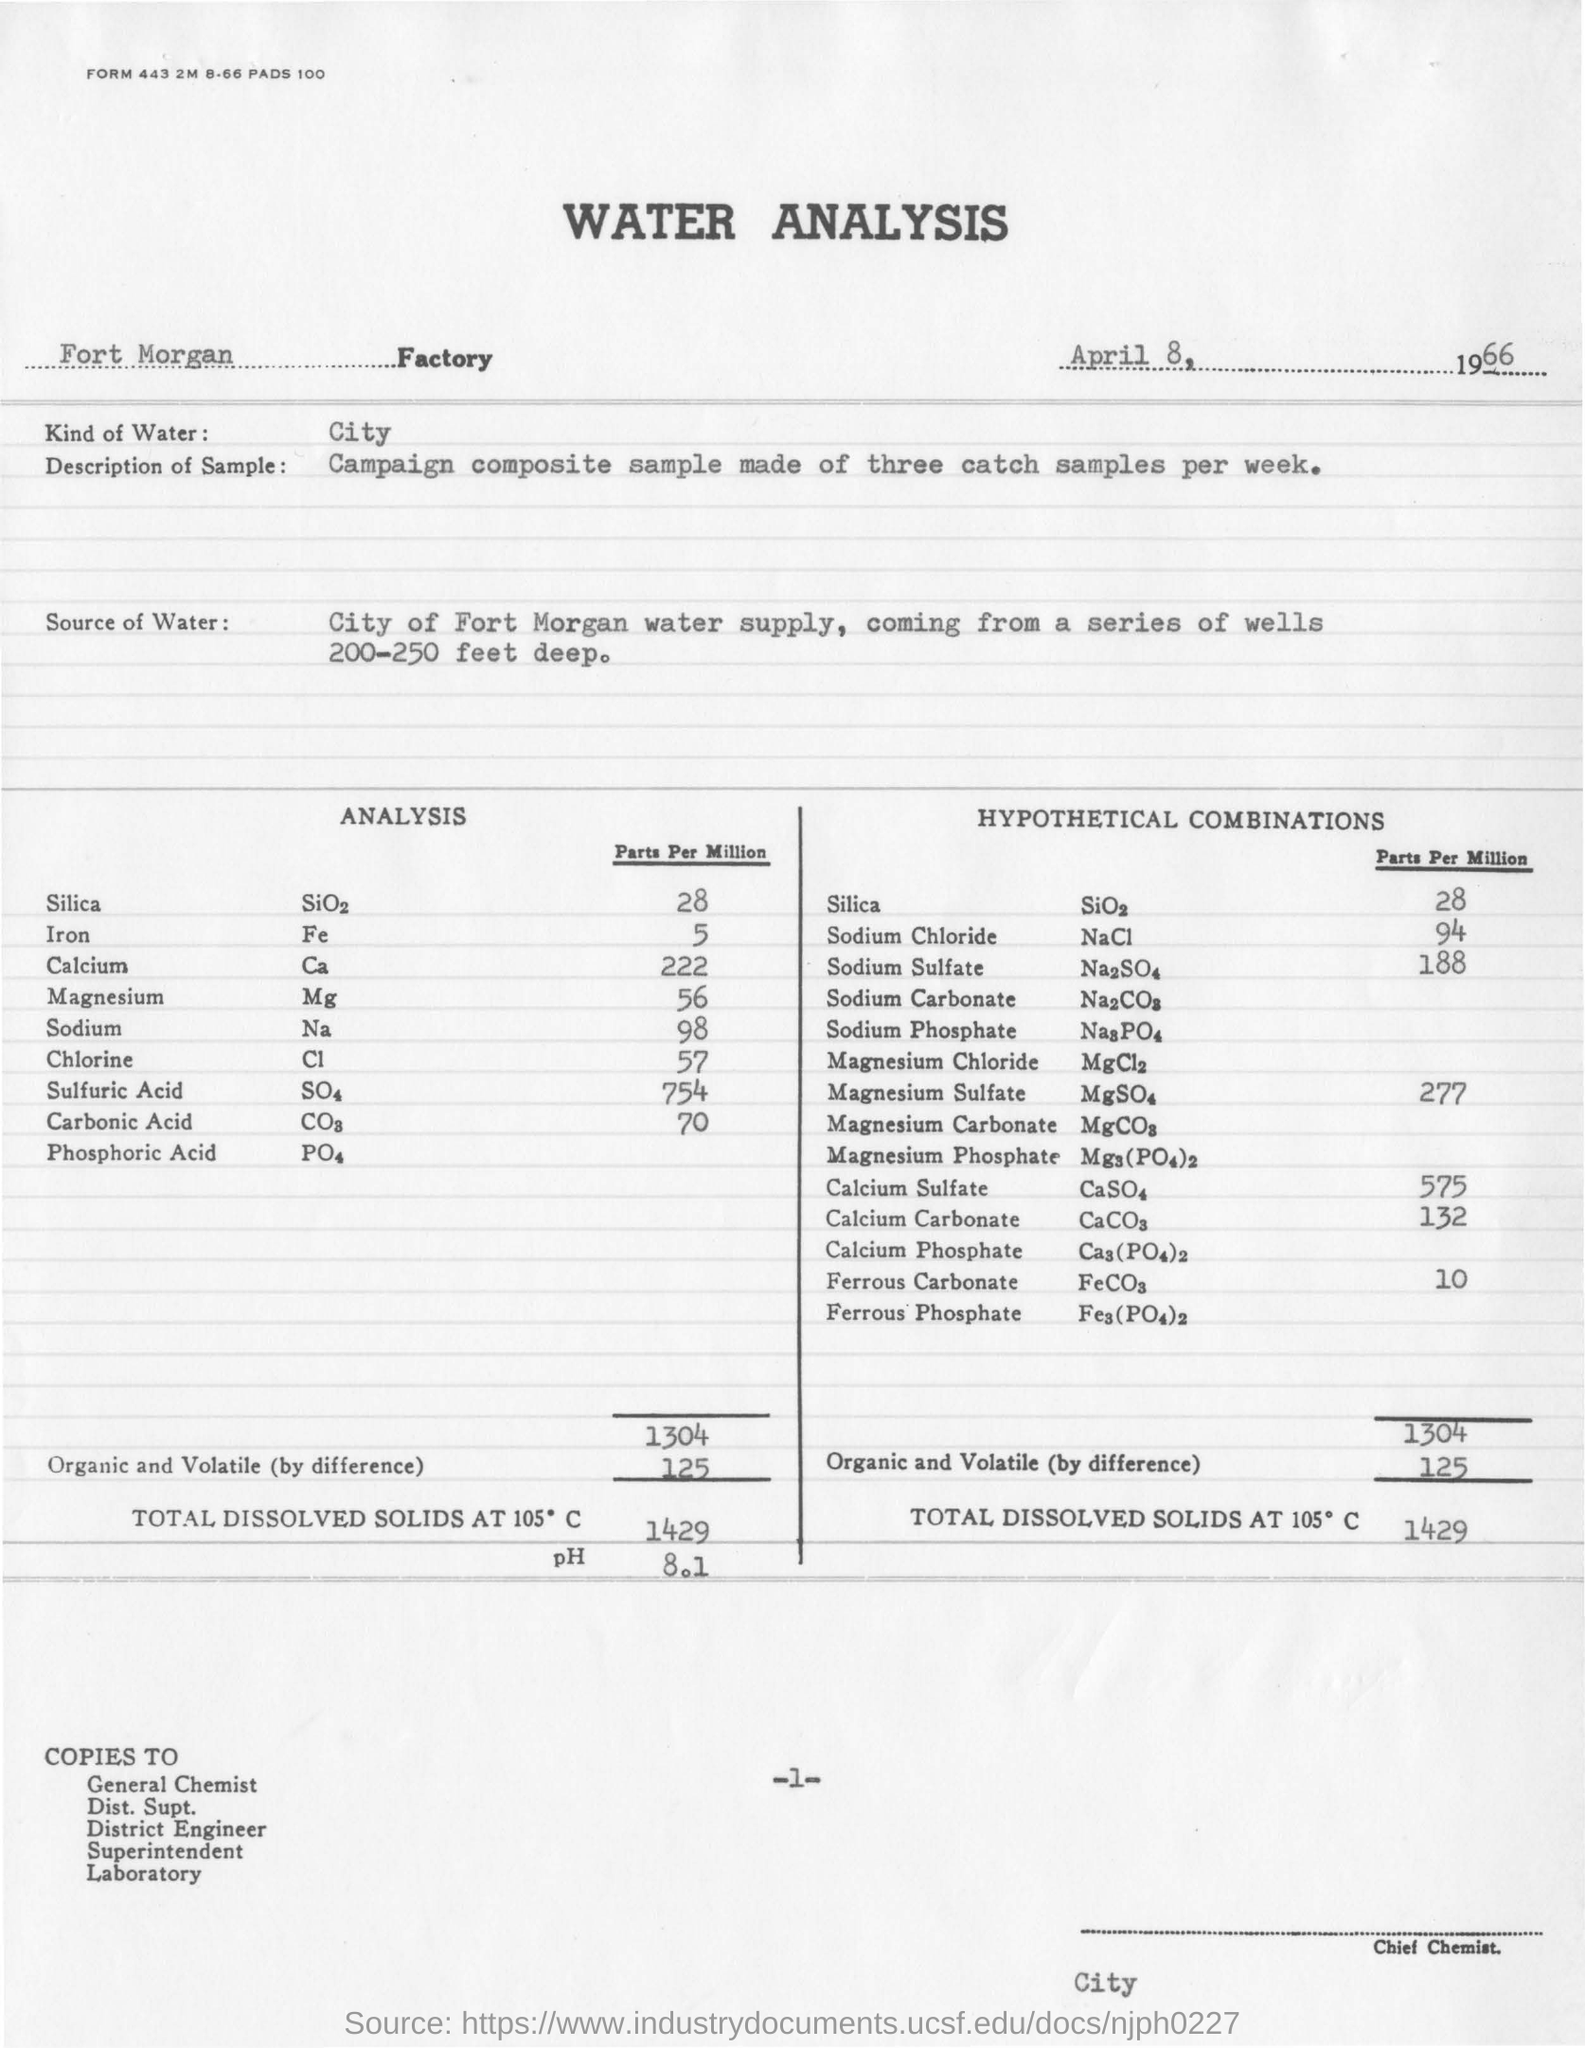Give some essential details in this illustration. The analysis is conducted at Factory in Fort Morgan. The quantity of Sodium chloride in hypothetical combinations is 94 parts per million. The value of pH in analysis is 8.1. This document mentions water analysis. The quantity of Calcium obtained in the analysis is 222 parts per million. 